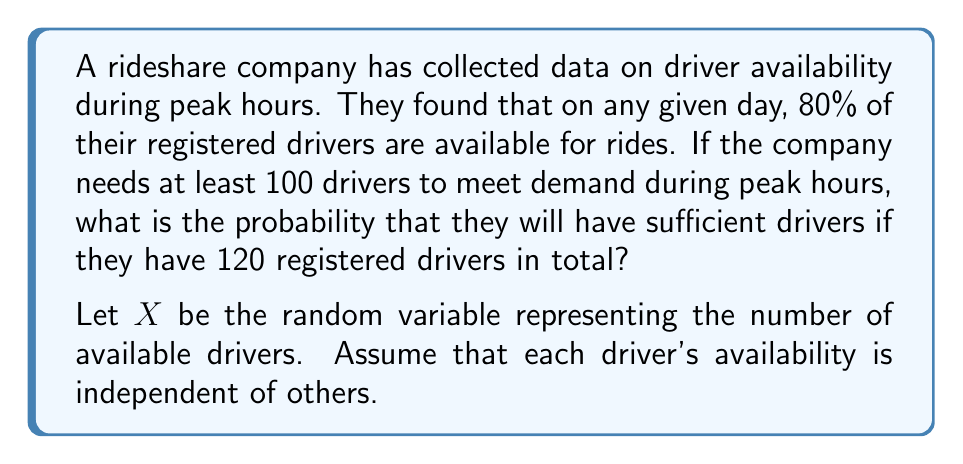Show me your answer to this math problem. To solve this problem, we'll use the binomial distribution and its normal approximation.

1) First, identify the parameters:
   $n = 120$ (total number of registered drivers)
   $p = 0.80$ (probability of a driver being available)
   $X \sim B(n,p)$ (X follows a binomial distribution)

2) We need to find $P(X \geq 100)$

3) For large $n$ and $p$ not too close to 0 or 1, we can approximate the binomial distribution with a normal distribution:

   $X \approx N(\mu, \sigma^2)$ where:
   $\mu = np = 120 \cdot 0.80 = 96$
   $\sigma^2 = np(1-p) = 120 \cdot 0.80 \cdot 0.20 = 19.2$
   $\sigma = \sqrt{19.2} \approx 4.38$

4) Applying continuity correction:
   $P(X \geq 100) = P(X > 99.5)$

5) Standardize the normal distribution:
   $z = \frac{99.5 - 96}{4.38} \approx 0.80$

6) Look up the z-score in a standard normal table or use a calculator:
   $P(Z > 0.80) \approx 0.2119$

Therefore, the probability of having at least 100 available drivers is approximately 0.2119 or 21.19%.
Answer: The probability that the company will have sufficient drivers (at least 100) during peak hours is approximately 0.2119 or 21.19%. 